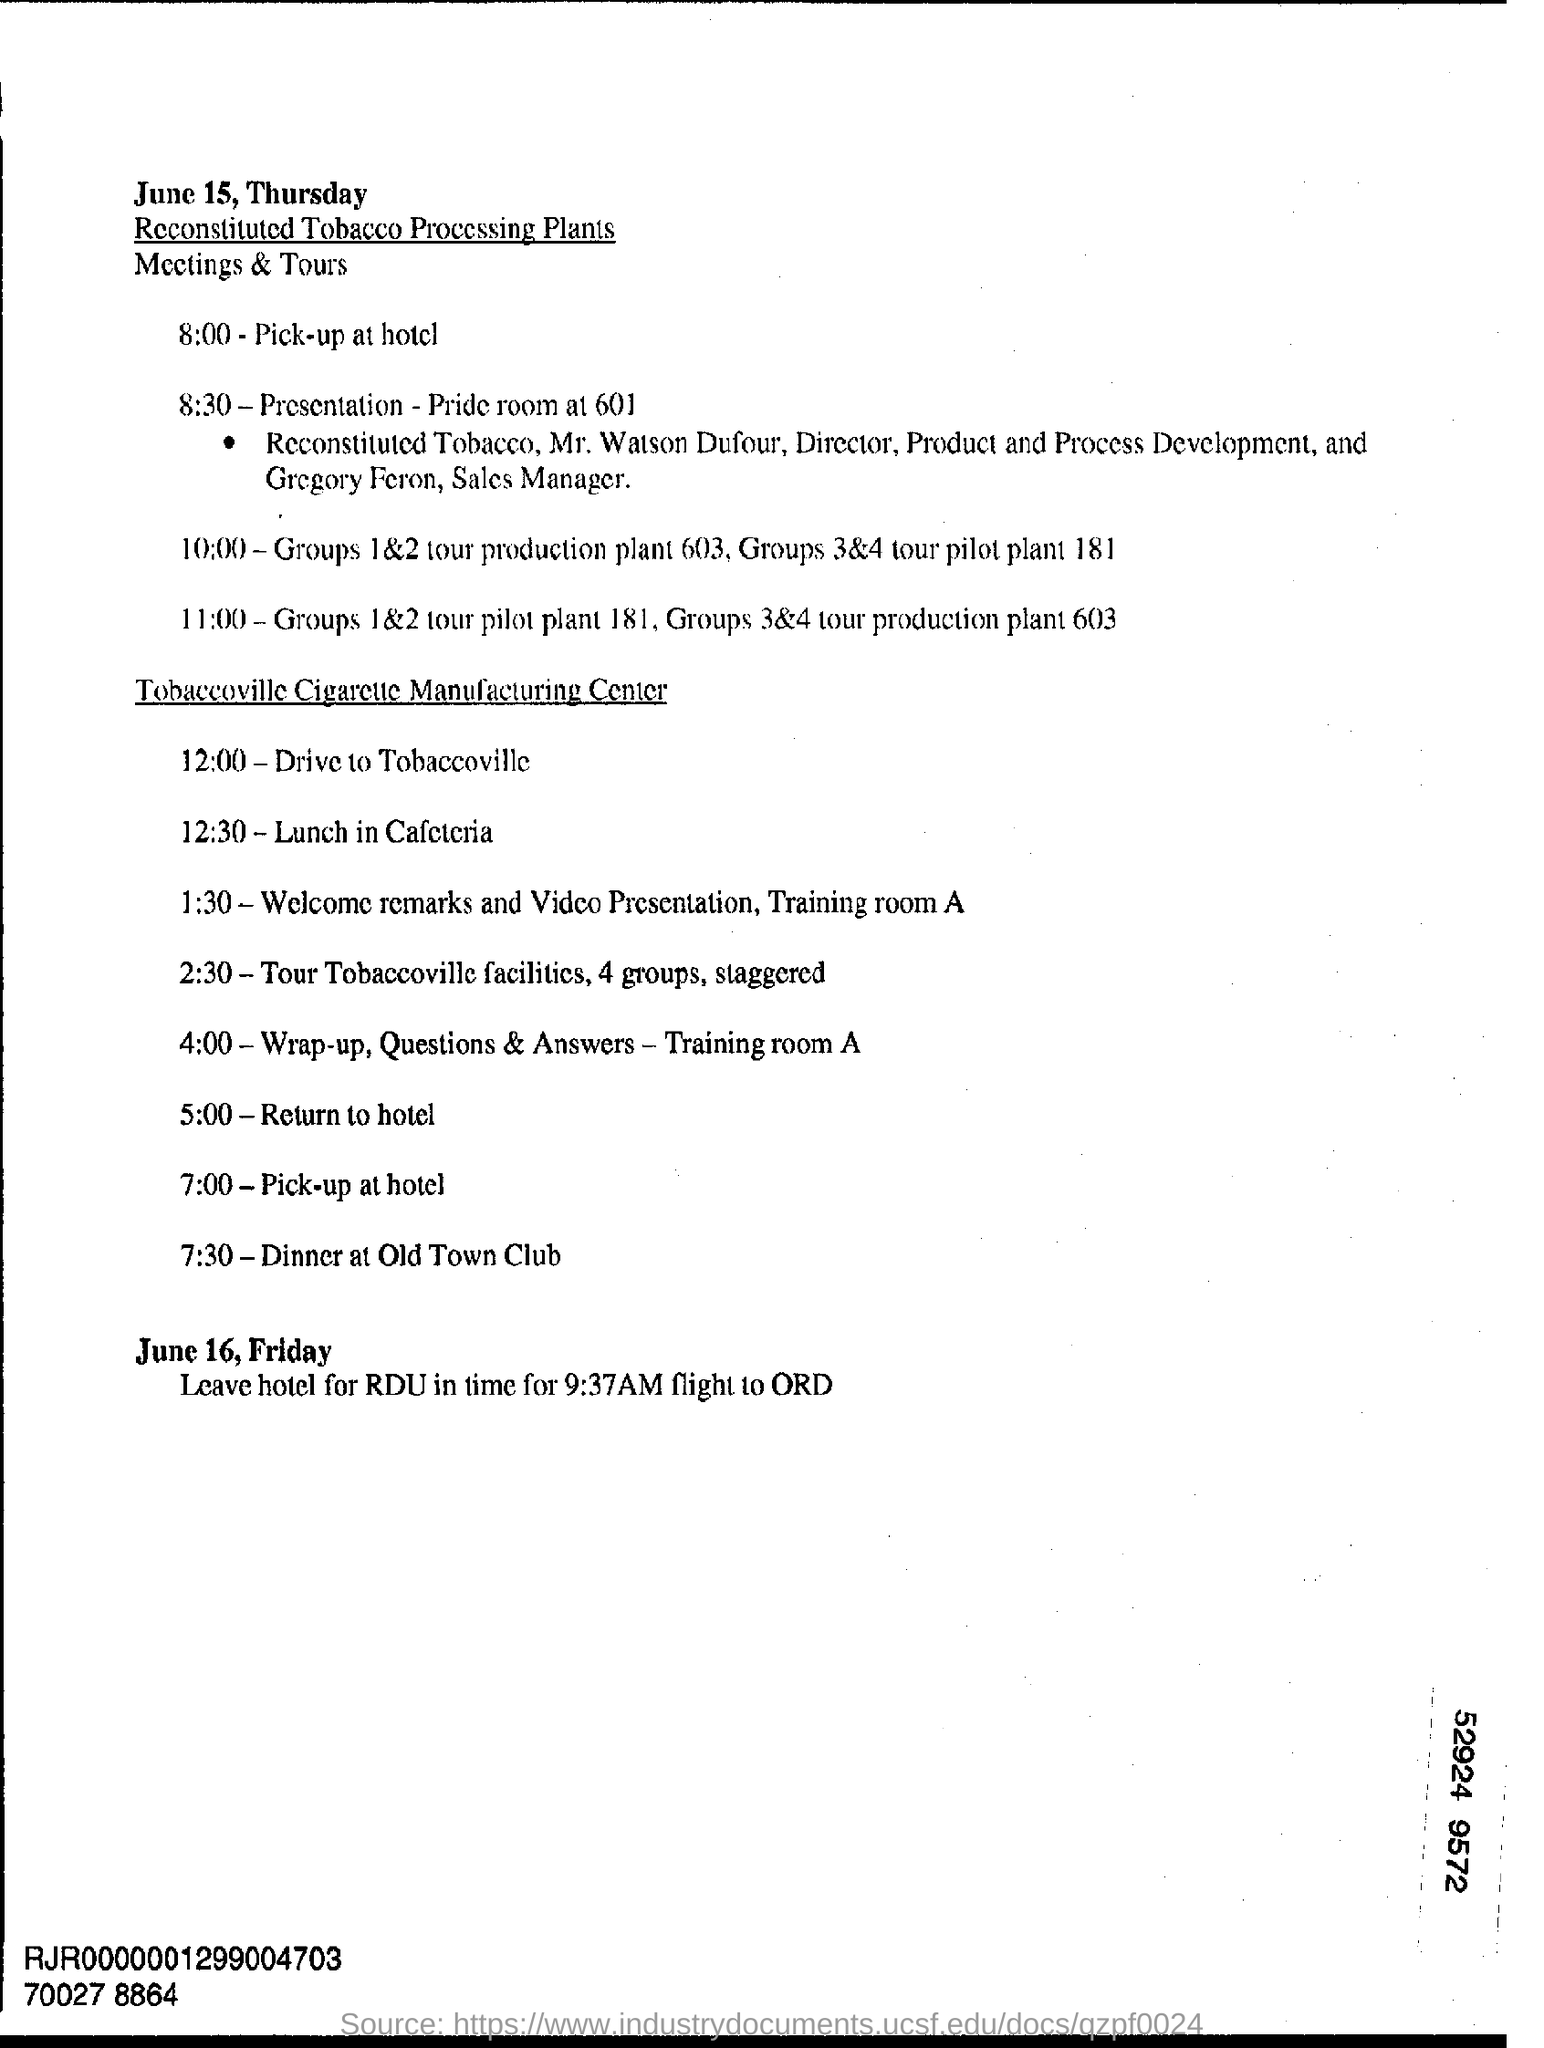Identify some key points in this picture. At 5:00 PM, their plan is to return to the hotel. It is scheduled for 12:00 PM that they will be driving to Tobaccoville. 